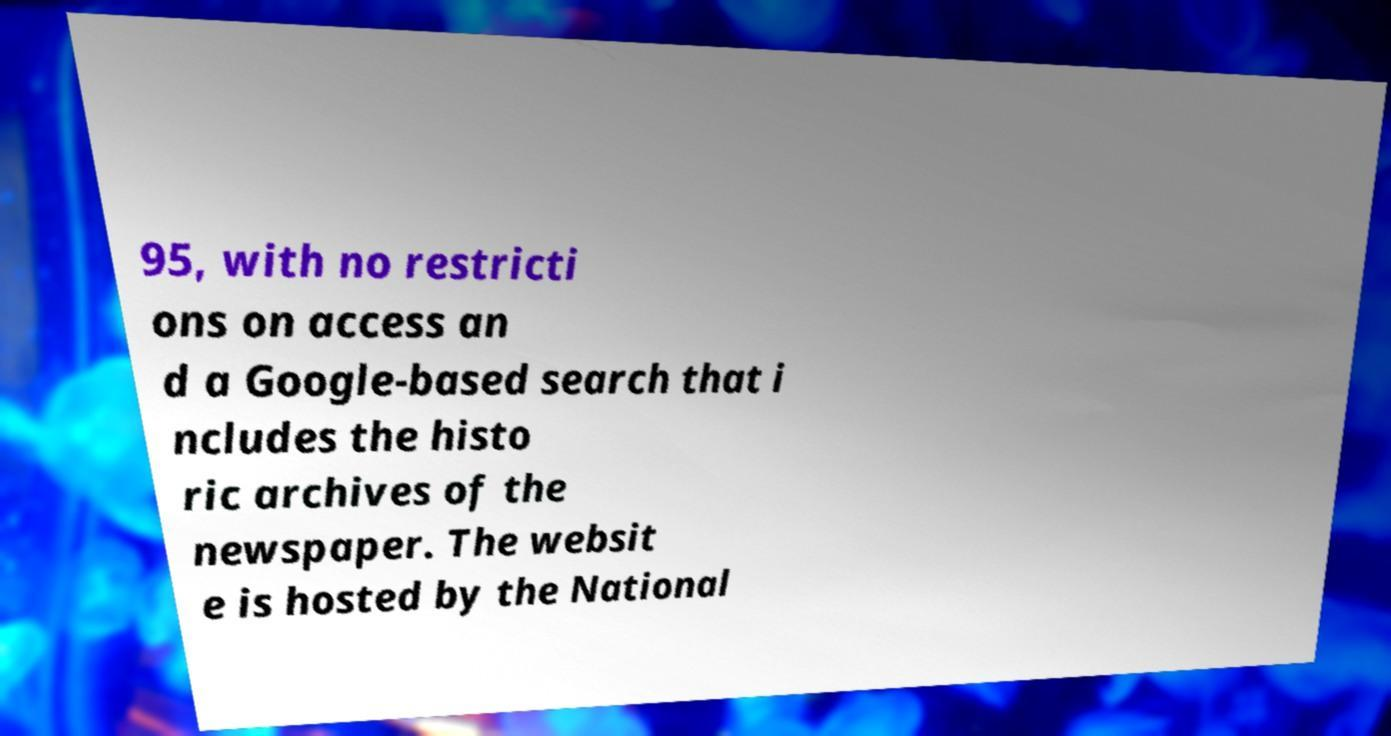Please read and relay the text visible in this image. What does it say? 95, with no restricti ons on access an d a Google-based search that i ncludes the histo ric archives of the newspaper. The websit e is hosted by the National 